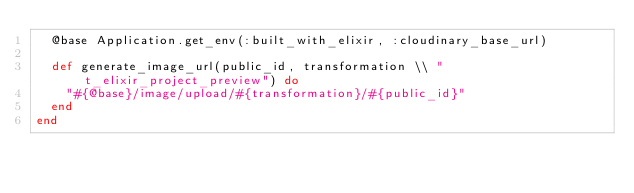Convert code to text. <code><loc_0><loc_0><loc_500><loc_500><_Elixir_>  @base Application.get_env(:built_with_elixir, :cloudinary_base_url)

  def generate_image_url(public_id, transformation \\ "t_elixir_project_preview") do
    "#{@base}/image/upload/#{transformation}/#{public_id}"
  end
end
</code> 